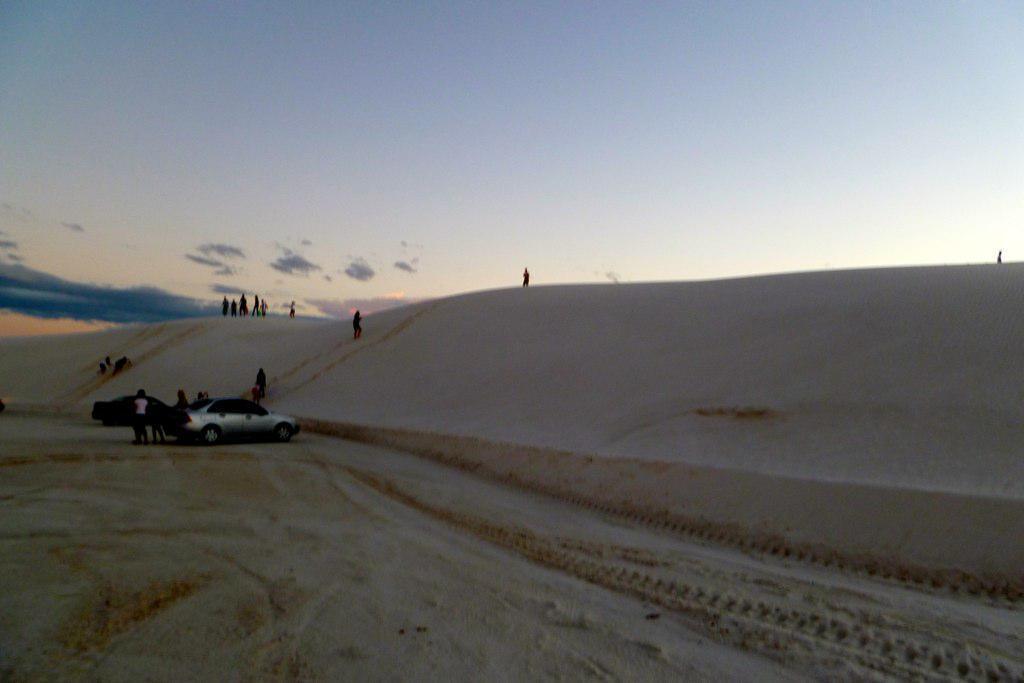In one or two sentences, can you explain what this image depicts? There is sand. On that there are two cars and people. In the back there is sky. 